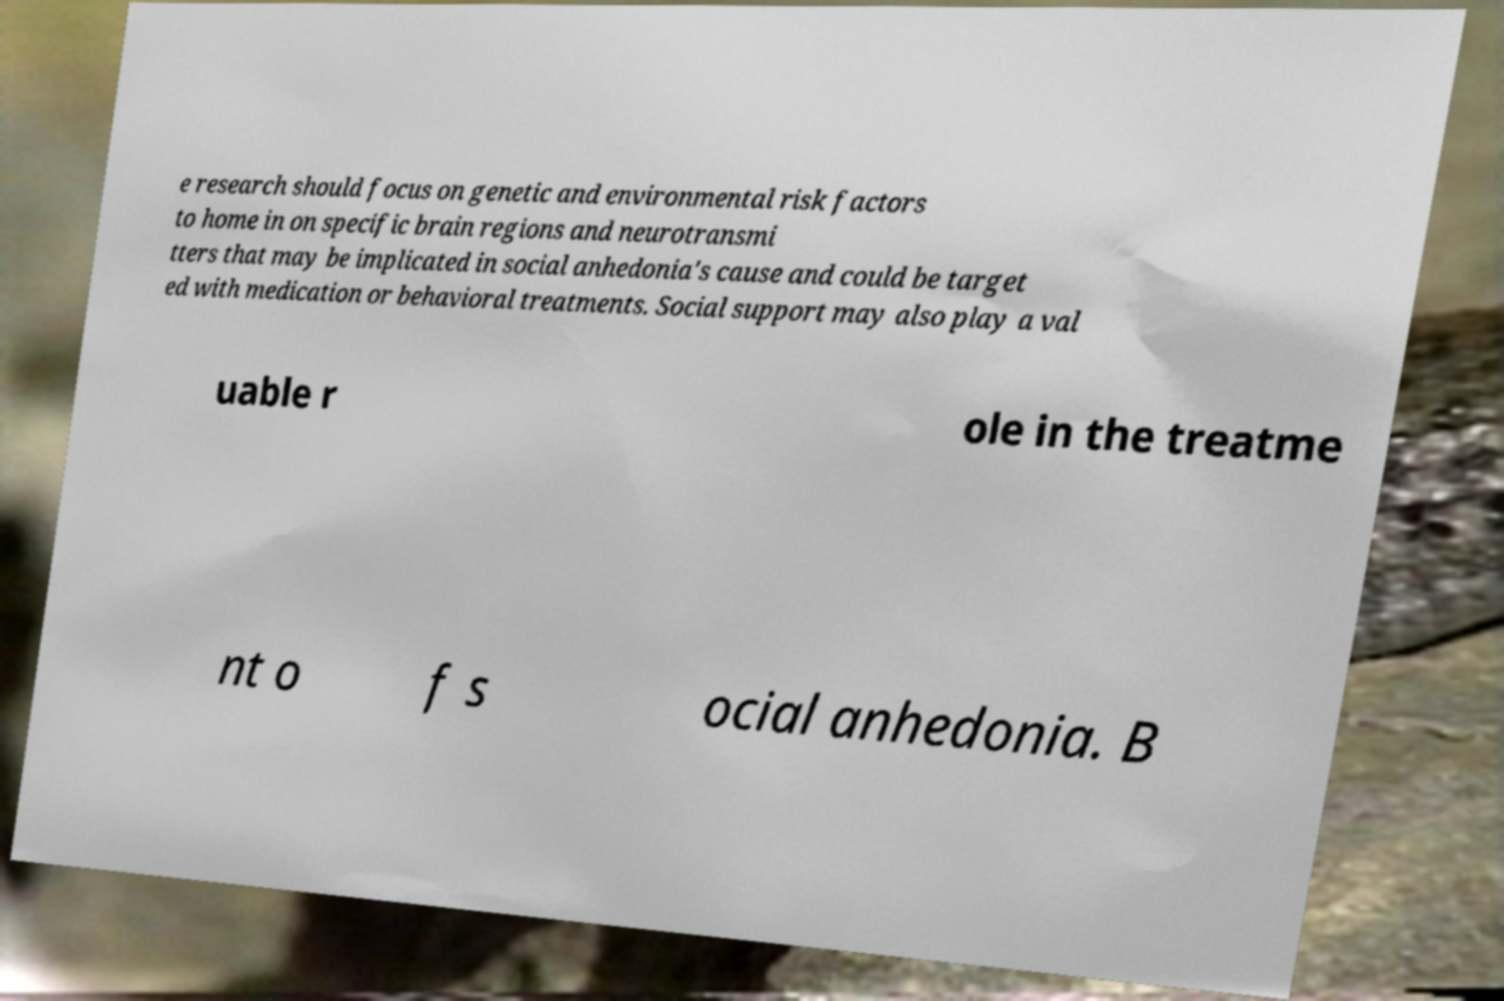There's text embedded in this image that I need extracted. Can you transcribe it verbatim? e research should focus on genetic and environmental risk factors to home in on specific brain regions and neurotransmi tters that may be implicated in social anhedonia's cause and could be target ed with medication or behavioral treatments. Social support may also play a val uable r ole in the treatme nt o f s ocial anhedonia. B 